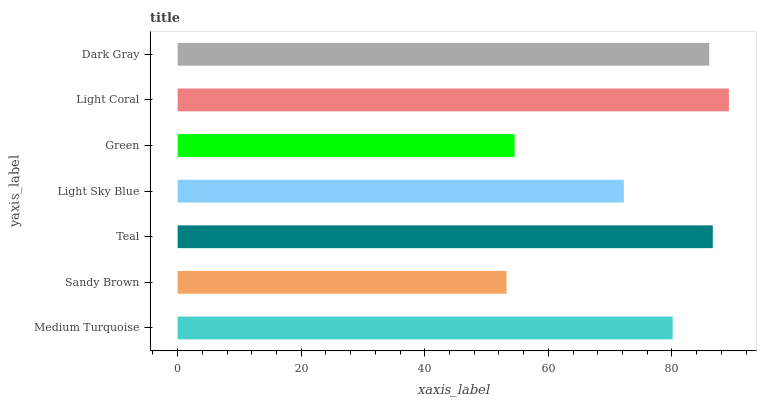Is Sandy Brown the minimum?
Answer yes or no. Yes. Is Light Coral the maximum?
Answer yes or no. Yes. Is Teal the minimum?
Answer yes or no. No. Is Teal the maximum?
Answer yes or no. No. Is Teal greater than Sandy Brown?
Answer yes or no. Yes. Is Sandy Brown less than Teal?
Answer yes or no. Yes. Is Sandy Brown greater than Teal?
Answer yes or no. No. Is Teal less than Sandy Brown?
Answer yes or no. No. Is Medium Turquoise the high median?
Answer yes or no. Yes. Is Medium Turquoise the low median?
Answer yes or no. Yes. Is Light Coral the high median?
Answer yes or no. No. Is Teal the low median?
Answer yes or no. No. 